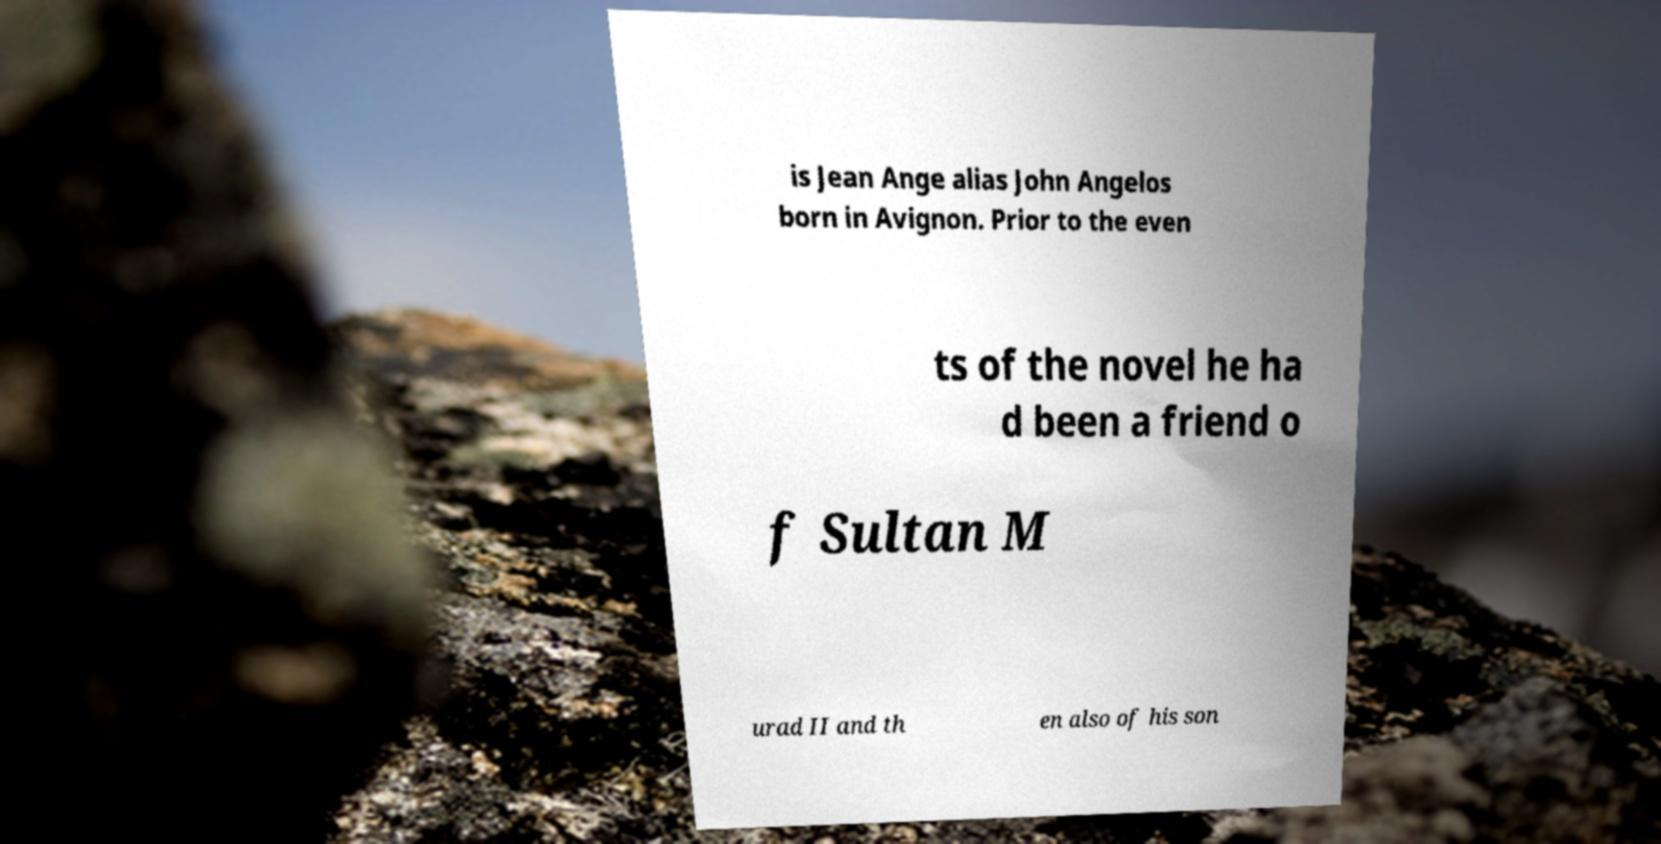There's text embedded in this image that I need extracted. Can you transcribe it verbatim? is Jean Ange alias John Angelos born in Avignon. Prior to the even ts of the novel he ha d been a friend o f Sultan M urad II and th en also of his son 